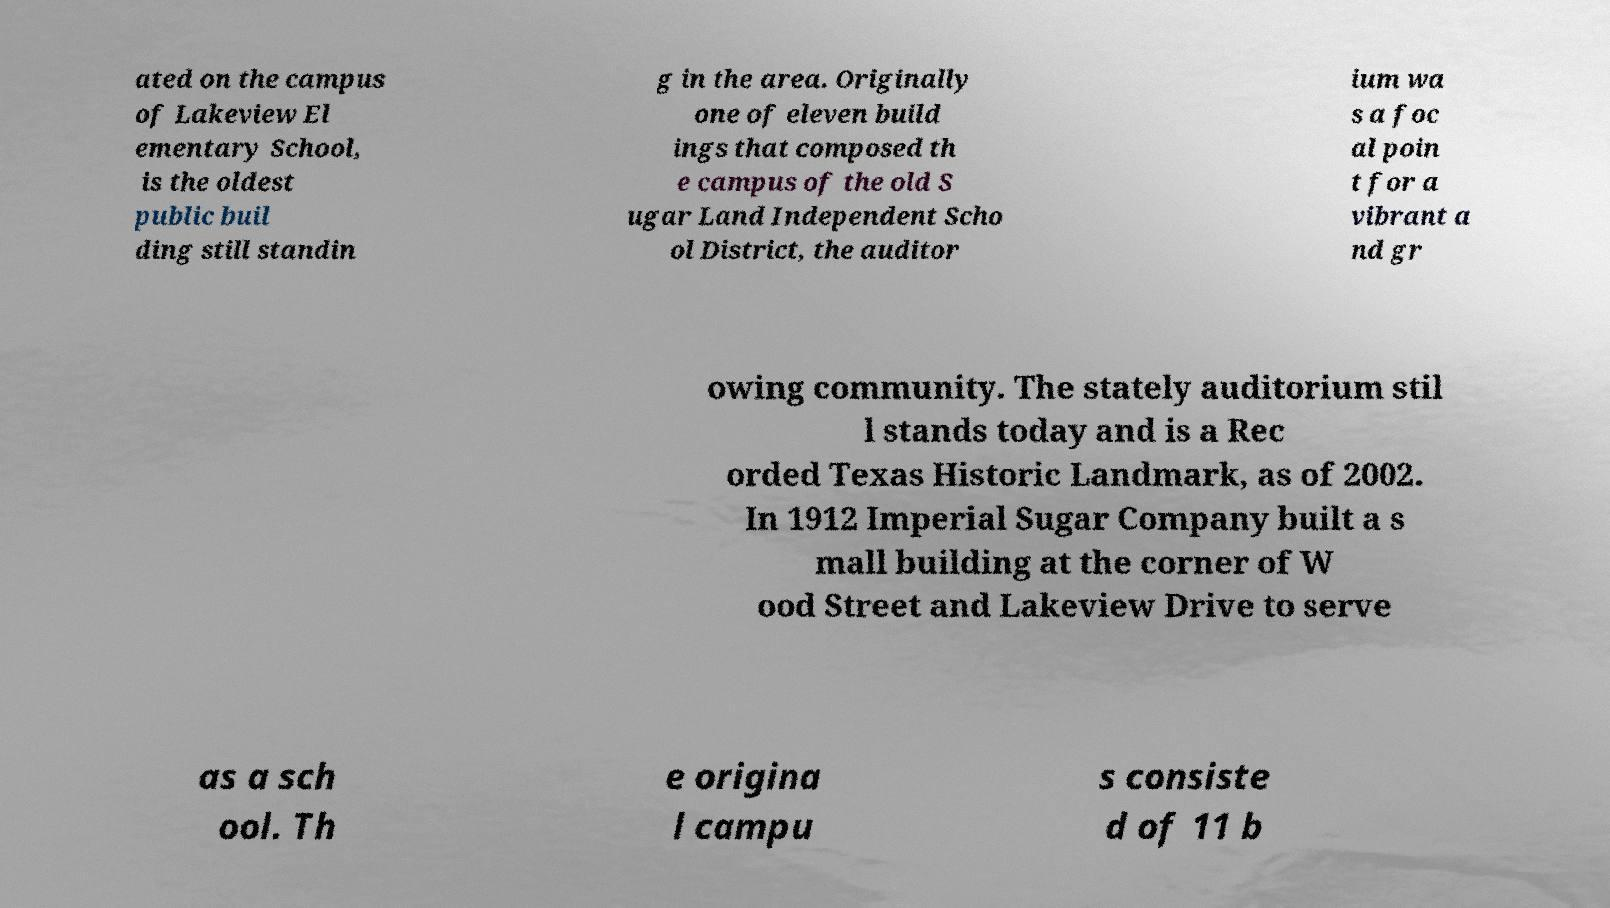Could you assist in decoding the text presented in this image and type it out clearly? ated on the campus of Lakeview El ementary School, is the oldest public buil ding still standin g in the area. Originally one of eleven build ings that composed th e campus of the old S ugar Land Independent Scho ol District, the auditor ium wa s a foc al poin t for a vibrant a nd gr owing community. The stately auditorium stil l stands today and is a Rec orded Texas Historic Landmark, as of 2002. In 1912 Imperial Sugar Company built a s mall building at the corner of W ood Street and Lakeview Drive to serve as a sch ool. Th e origina l campu s consiste d of 11 b 